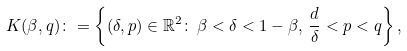<formula> <loc_0><loc_0><loc_500><loc_500>K ( \beta , q ) \colon = \left \{ ( \delta , p ) \in \mathbb { R } ^ { 2 } \colon \, \beta < \delta < 1 - \beta , \, \frac { d } { \delta } < p < q \right \} ,</formula> 